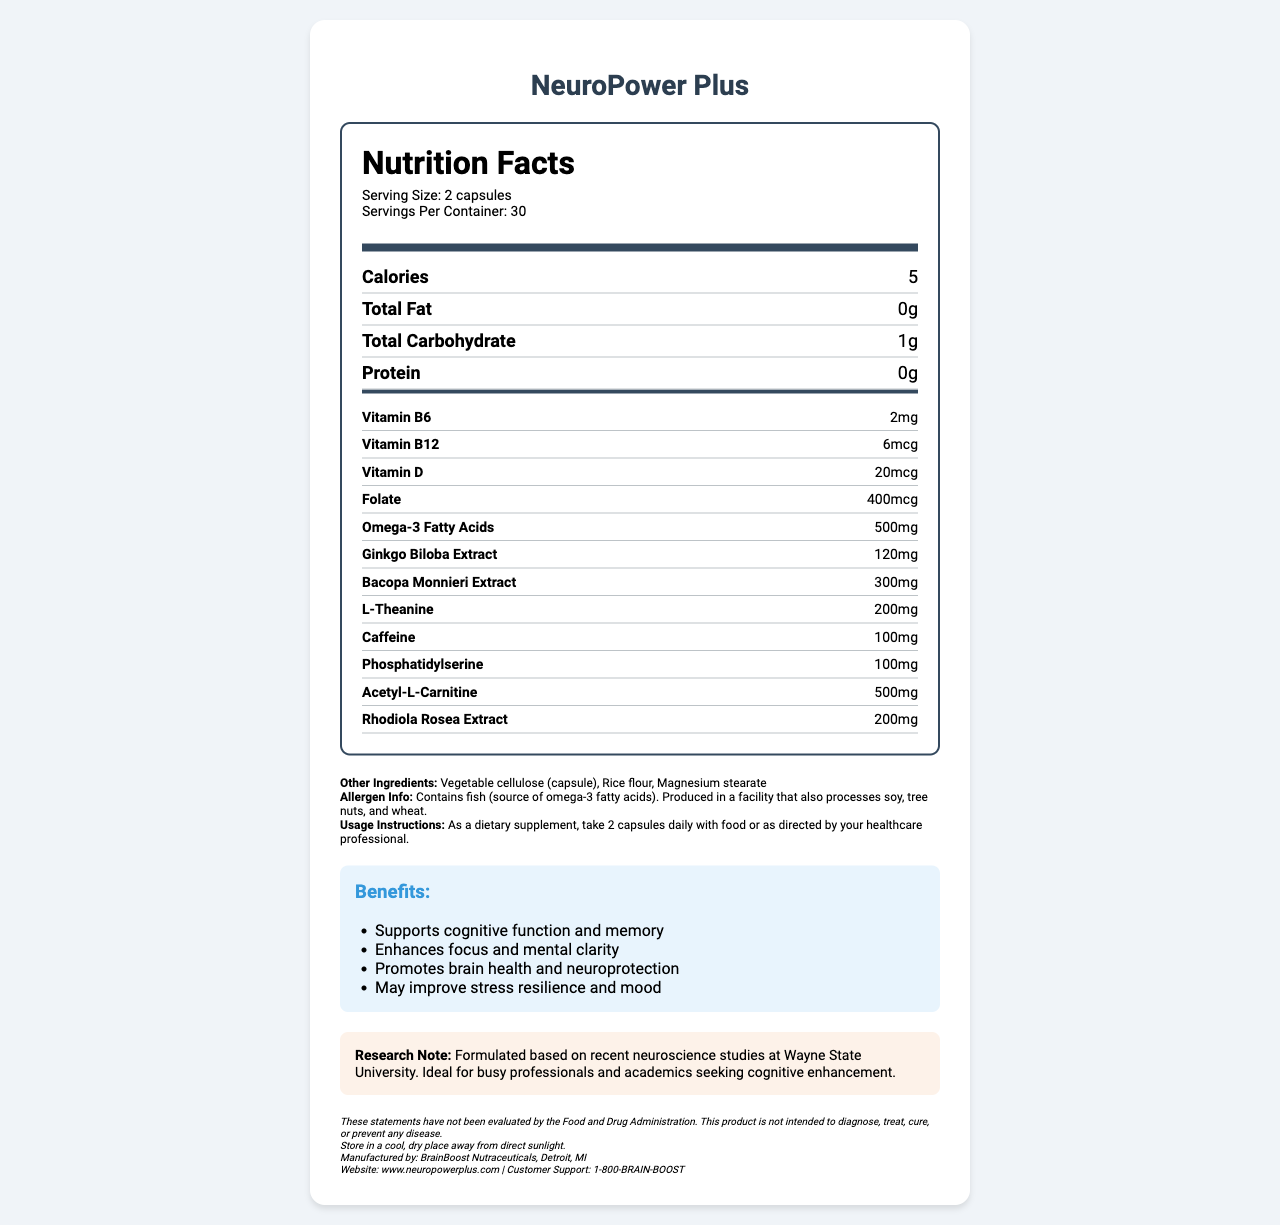what is the serving size of NeuroPower Plus? The serving size is explicitly mentioned under the "Serving Size" in the nutrition facts section.
Answer: 2 capsules how many servings are there per container? The number of servings per container is clearly indicated as 30 under the "Servings Per Container" section.
Answer: 30 how many calories are in one serving of NeuroPower Plus? The calories per serving are specified as 5 in the nutrition facts.
Answer: 5 which ingredient is the main source of omega-3 fatty acids? The allergen info states the supplement contains fish as the source of omega-3 fatty acids.
Answer: Fish what is the amount of Vitamin B6 in each serving? The amount of Vitamin B6 per serving is listed as 2mg in the sub-nutrients section.
Answer: 2mg how much caffeine is in each serving? A. 50mg B. 100mg C. 200mg The nutrition facts label shows that each serving contains 100mg of caffeine.
Answer: B. 100mg which of these ingredients is NOT listed in the supplement? A. Ginkgo Biloba Extract B. Bacopa Monnieri Extract C. Ginseng Extract Ginkgo Biloba Extract and Bacopa Monnieri Extract are listed in the sub-nutrients, but Ginseng Extract is not mentioned.
Answer: C. Ginseng Extract is the serving size 5 capsules? The serving size is 2 capsules, not 5 as specified in the serving size section.
Answer: No does this supplement support cognitive function? One of the listed benefits is that it supports cognitive function and memory.
Answer: Yes what are the benefits of NeuroPower Plus? The document lists these specific benefits in the "Benefits" section.
Answer: Supports cognitive function and memory, enhances focus and mental clarity, promotes brain health and neuroprotection, may improve stress resilience and mood summarize the document. The summary includes the product's name, purpose, main ingredients, associated benefits, manufacturer details, and allergen information.
Answer: NeuroPower Plus is a brain-boosting supplement designed to enhance cognitive function, focus, and mental clarity. Each serving consists of 2 capsules with a variety of ingredients like omega-3 fatty acids, ginkgo biloba, bacopa monnieri, and caffeine. It contains vitamins B6, B12, D, and folate, among other nutrients, and is produced by BrainBoost Nutraceuticals in Detroit, MI. The product claims to support cognitive function and memory, promote brain health, and improve stress resilience and mood. It contains fish (source of omega-3) and is produced in a facility that processes soy, tree nuts, and wheat. who is the manufacturer of NeuroPower Plus? The manufacturer's information is at the end of the document under storage, manufacturer, website, and support details.
Answer: BrainBoost Nutraceuticals, Detroit, MI does NeuroPower Plus cure diseases? The disclaimer states that the product is not intended to diagnose, treat, cure, or prevent any disease.
Answer: No where was NeuroPower Plus formulated? The research note indicates that the product was formulated based on recent neuroscience studies at Wayne State University.
Answer: Wayne State University does the document mention the RDA (Recommended Dietary Allowance) for any nutrients? The document provides the amount of each nutrient per serving but does not mention the recommended dietary allowance (RDA) for any of them.
Answer: Not enough information 